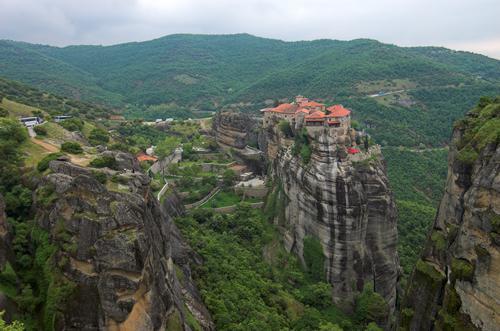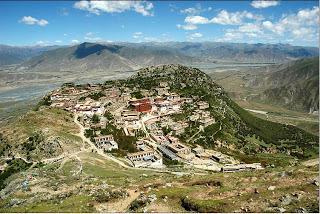The first image is the image on the left, the second image is the image on the right. Analyze the images presented: Is the assertion "There are a set of red brick topped buildings sitting on the edge of a cliff." valid? Answer yes or no. Yes. The first image is the image on the left, the second image is the image on the right. Given the left and right images, does the statement "We see at least one mansion, built onto a skinny cliff; there certainly isn't enough room for a town." hold true? Answer yes or no. Yes. 